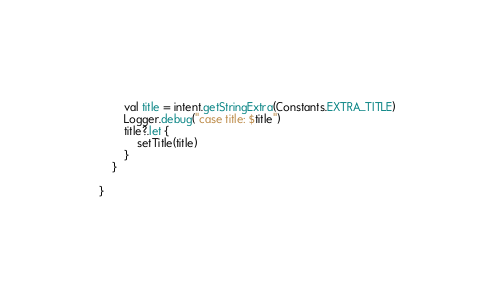Convert code to text. <code><loc_0><loc_0><loc_500><loc_500><_Kotlin_>        val title = intent.getStringExtra(Constants.EXTRA_TITLE)
        Logger.debug("case title: $title")
        title?.let {
            setTitle(title)
        }
    }

}</code> 